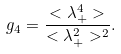Convert formula to latex. <formula><loc_0><loc_0><loc_500><loc_500>g _ { 4 } = \frac { < \lambda _ { + } ^ { 4 } > } { < \lambda _ { + } ^ { 2 } > ^ { 2 } } .</formula> 